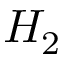<formula> <loc_0><loc_0><loc_500><loc_500>H _ { 2 }</formula> 